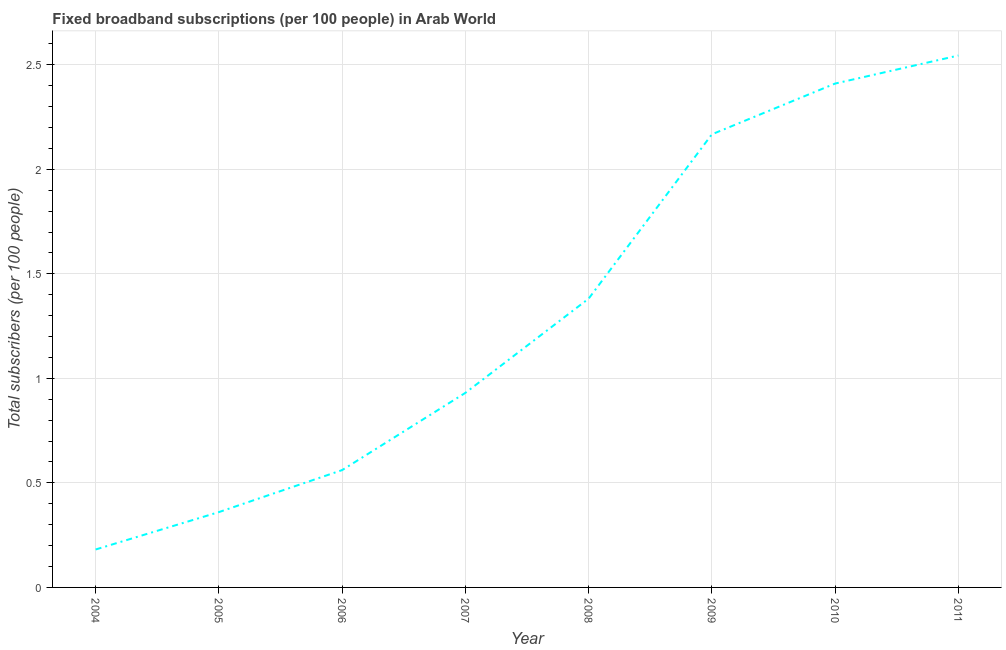What is the total number of fixed broadband subscriptions in 2004?
Give a very brief answer. 0.18. Across all years, what is the maximum total number of fixed broadband subscriptions?
Your response must be concise. 2.54. Across all years, what is the minimum total number of fixed broadband subscriptions?
Your answer should be compact. 0.18. What is the sum of the total number of fixed broadband subscriptions?
Offer a terse response. 10.54. What is the difference between the total number of fixed broadband subscriptions in 2004 and 2008?
Your answer should be very brief. -1.2. What is the average total number of fixed broadband subscriptions per year?
Your answer should be very brief. 1.32. What is the median total number of fixed broadband subscriptions?
Offer a terse response. 1.16. What is the ratio of the total number of fixed broadband subscriptions in 2007 to that in 2011?
Provide a short and direct response. 0.37. Is the total number of fixed broadband subscriptions in 2004 less than that in 2008?
Offer a terse response. Yes. Is the difference between the total number of fixed broadband subscriptions in 2008 and 2009 greater than the difference between any two years?
Provide a short and direct response. No. What is the difference between the highest and the second highest total number of fixed broadband subscriptions?
Make the answer very short. 0.13. What is the difference between the highest and the lowest total number of fixed broadband subscriptions?
Your answer should be compact. 2.36. In how many years, is the total number of fixed broadband subscriptions greater than the average total number of fixed broadband subscriptions taken over all years?
Make the answer very short. 4. How many lines are there?
Provide a short and direct response. 1. How many years are there in the graph?
Your response must be concise. 8. Are the values on the major ticks of Y-axis written in scientific E-notation?
Make the answer very short. No. Does the graph contain any zero values?
Provide a succinct answer. No. What is the title of the graph?
Keep it short and to the point. Fixed broadband subscriptions (per 100 people) in Arab World. What is the label or title of the X-axis?
Offer a very short reply. Year. What is the label or title of the Y-axis?
Your response must be concise. Total subscribers (per 100 people). What is the Total subscribers (per 100 people) in 2004?
Give a very brief answer. 0.18. What is the Total subscribers (per 100 people) in 2005?
Your response must be concise. 0.36. What is the Total subscribers (per 100 people) in 2006?
Your answer should be very brief. 0.56. What is the Total subscribers (per 100 people) of 2007?
Give a very brief answer. 0.93. What is the Total subscribers (per 100 people) in 2008?
Give a very brief answer. 1.38. What is the Total subscribers (per 100 people) of 2009?
Your answer should be compact. 2.17. What is the Total subscribers (per 100 people) of 2010?
Provide a short and direct response. 2.41. What is the Total subscribers (per 100 people) in 2011?
Offer a very short reply. 2.54. What is the difference between the Total subscribers (per 100 people) in 2004 and 2005?
Ensure brevity in your answer.  -0.18. What is the difference between the Total subscribers (per 100 people) in 2004 and 2006?
Ensure brevity in your answer.  -0.38. What is the difference between the Total subscribers (per 100 people) in 2004 and 2007?
Your response must be concise. -0.75. What is the difference between the Total subscribers (per 100 people) in 2004 and 2008?
Provide a short and direct response. -1.2. What is the difference between the Total subscribers (per 100 people) in 2004 and 2009?
Provide a short and direct response. -1.99. What is the difference between the Total subscribers (per 100 people) in 2004 and 2010?
Make the answer very short. -2.23. What is the difference between the Total subscribers (per 100 people) in 2004 and 2011?
Provide a succinct answer. -2.36. What is the difference between the Total subscribers (per 100 people) in 2005 and 2006?
Provide a short and direct response. -0.2. What is the difference between the Total subscribers (per 100 people) in 2005 and 2007?
Make the answer very short. -0.57. What is the difference between the Total subscribers (per 100 people) in 2005 and 2008?
Make the answer very short. -1.02. What is the difference between the Total subscribers (per 100 people) in 2005 and 2009?
Offer a terse response. -1.81. What is the difference between the Total subscribers (per 100 people) in 2005 and 2010?
Your response must be concise. -2.05. What is the difference between the Total subscribers (per 100 people) in 2005 and 2011?
Offer a terse response. -2.18. What is the difference between the Total subscribers (per 100 people) in 2006 and 2007?
Offer a terse response. -0.37. What is the difference between the Total subscribers (per 100 people) in 2006 and 2008?
Ensure brevity in your answer.  -0.82. What is the difference between the Total subscribers (per 100 people) in 2006 and 2009?
Offer a terse response. -1.61. What is the difference between the Total subscribers (per 100 people) in 2006 and 2010?
Your answer should be very brief. -1.85. What is the difference between the Total subscribers (per 100 people) in 2006 and 2011?
Your response must be concise. -1.98. What is the difference between the Total subscribers (per 100 people) in 2007 and 2008?
Keep it short and to the point. -0.45. What is the difference between the Total subscribers (per 100 people) in 2007 and 2009?
Ensure brevity in your answer.  -1.24. What is the difference between the Total subscribers (per 100 people) in 2007 and 2010?
Make the answer very short. -1.48. What is the difference between the Total subscribers (per 100 people) in 2007 and 2011?
Keep it short and to the point. -1.61. What is the difference between the Total subscribers (per 100 people) in 2008 and 2009?
Provide a succinct answer. -0.79. What is the difference between the Total subscribers (per 100 people) in 2008 and 2010?
Make the answer very short. -1.03. What is the difference between the Total subscribers (per 100 people) in 2008 and 2011?
Keep it short and to the point. -1.16. What is the difference between the Total subscribers (per 100 people) in 2009 and 2010?
Provide a short and direct response. -0.24. What is the difference between the Total subscribers (per 100 people) in 2009 and 2011?
Provide a short and direct response. -0.38. What is the difference between the Total subscribers (per 100 people) in 2010 and 2011?
Offer a very short reply. -0.13. What is the ratio of the Total subscribers (per 100 people) in 2004 to that in 2005?
Ensure brevity in your answer.  0.5. What is the ratio of the Total subscribers (per 100 people) in 2004 to that in 2006?
Ensure brevity in your answer.  0.32. What is the ratio of the Total subscribers (per 100 people) in 2004 to that in 2007?
Ensure brevity in your answer.  0.2. What is the ratio of the Total subscribers (per 100 people) in 2004 to that in 2008?
Offer a terse response. 0.13. What is the ratio of the Total subscribers (per 100 people) in 2004 to that in 2009?
Provide a succinct answer. 0.08. What is the ratio of the Total subscribers (per 100 people) in 2004 to that in 2010?
Ensure brevity in your answer.  0.07. What is the ratio of the Total subscribers (per 100 people) in 2004 to that in 2011?
Ensure brevity in your answer.  0.07. What is the ratio of the Total subscribers (per 100 people) in 2005 to that in 2006?
Provide a succinct answer. 0.64. What is the ratio of the Total subscribers (per 100 people) in 2005 to that in 2007?
Your answer should be compact. 0.39. What is the ratio of the Total subscribers (per 100 people) in 2005 to that in 2008?
Your answer should be very brief. 0.26. What is the ratio of the Total subscribers (per 100 people) in 2005 to that in 2009?
Your answer should be compact. 0.17. What is the ratio of the Total subscribers (per 100 people) in 2005 to that in 2010?
Make the answer very short. 0.15. What is the ratio of the Total subscribers (per 100 people) in 2005 to that in 2011?
Ensure brevity in your answer.  0.14. What is the ratio of the Total subscribers (per 100 people) in 2006 to that in 2007?
Your answer should be very brief. 0.6. What is the ratio of the Total subscribers (per 100 people) in 2006 to that in 2008?
Provide a succinct answer. 0.41. What is the ratio of the Total subscribers (per 100 people) in 2006 to that in 2009?
Ensure brevity in your answer.  0.26. What is the ratio of the Total subscribers (per 100 people) in 2006 to that in 2010?
Offer a terse response. 0.23. What is the ratio of the Total subscribers (per 100 people) in 2006 to that in 2011?
Keep it short and to the point. 0.22. What is the ratio of the Total subscribers (per 100 people) in 2007 to that in 2008?
Ensure brevity in your answer.  0.67. What is the ratio of the Total subscribers (per 100 people) in 2007 to that in 2009?
Keep it short and to the point. 0.43. What is the ratio of the Total subscribers (per 100 people) in 2007 to that in 2010?
Ensure brevity in your answer.  0.39. What is the ratio of the Total subscribers (per 100 people) in 2007 to that in 2011?
Your answer should be very brief. 0.37. What is the ratio of the Total subscribers (per 100 people) in 2008 to that in 2009?
Your answer should be very brief. 0.64. What is the ratio of the Total subscribers (per 100 people) in 2008 to that in 2010?
Your answer should be compact. 0.57. What is the ratio of the Total subscribers (per 100 people) in 2008 to that in 2011?
Ensure brevity in your answer.  0.54. What is the ratio of the Total subscribers (per 100 people) in 2009 to that in 2010?
Give a very brief answer. 0.9. What is the ratio of the Total subscribers (per 100 people) in 2009 to that in 2011?
Ensure brevity in your answer.  0.85. What is the ratio of the Total subscribers (per 100 people) in 2010 to that in 2011?
Provide a short and direct response. 0.95. 